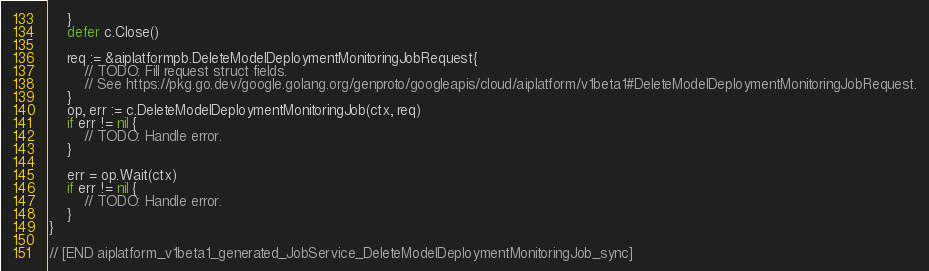Convert code to text. <code><loc_0><loc_0><loc_500><loc_500><_Go_>	}
	defer c.Close()

	req := &aiplatformpb.DeleteModelDeploymentMonitoringJobRequest{
		// TODO: Fill request struct fields.
		// See https://pkg.go.dev/google.golang.org/genproto/googleapis/cloud/aiplatform/v1beta1#DeleteModelDeploymentMonitoringJobRequest.
	}
	op, err := c.DeleteModelDeploymentMonitoringJob(ctx, req)
	if err != nil {
		// TODO: Handle error.
	}

	err = op.Wait(ctx)
	if err != nil {
		// TODO: Handle error.
	}
}

// [END aiplatform_v1beta1_generated_JobService_DeleteModelDeploymentMonitoringJob_sync]
</code> 